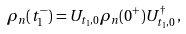<formula> <loc_0><loc_0><loc_500><loc_500>\rho _ { n } ( t _ { 1 } ^ { - } ) = U _ { t _ { 1 } , 0 } \rho _ { n } ( 0 ^ { + } ) U _ { t _ { 1 } , 0 } ^ { \dagger } \, ,</formula> 